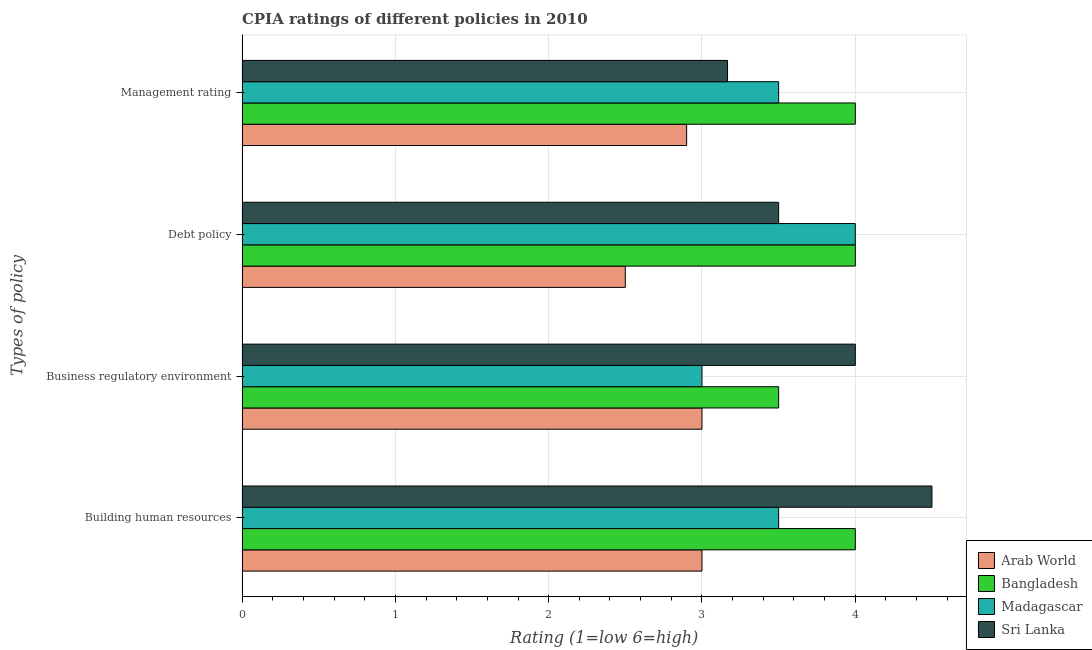How many groups of bars are there?
Provide a short and direct response. 4. How many bars are there on the 1st tick from the top?
Your answer should be very brief. 4. What is the label of the 2nd group of bars from the top?
Your answer should be compact. Debt policy. What is the cpia rating of debt policy in Arab World?
Provide a succinct answer. 2.5. Across all countries, what is the maximum cpia rating of building human resources?
Ensure brevity in your answer.  4.5. In which country was the cpia rating of building human resources maximum?
Offer a very short reply. Sri Lanka. In which country was the cpia rating of building human resources minimum?
Ensure brevity in your answer.  Arab World. What is the total cpia rating of business regulatory environment in the graph?
Make the answer very short. 13.5. What is the difference between the cpia rating of debt policy in Sri Lanka and the cpia rating of management in Arab World?
Make the answer very short. 0.6. What is the average cpia rating of management per country?
Give a very brief answer. 3.39. What is the difference between the cpia rating of management and cpia rating of debt policy in Arab World?
Your answer should be compact. 0.4. What is the ratio of the cpia rating of business regulatory environment in Sri Lanka to that in Bangladesh?
Your answer should be very brief. 1.14. Is the cpia rating of building human resources in Bangladesh less than that in Arab World?
Give a very brief answer. No. Is the difference between the cpia rating of debt policy in Bangladesh and Arab World greater than the difference between the cpia rating of building human resources in Bangladesh and Arab World?
Provide a short and direct response. Yes. What is the difference between the highest and the second highest cpia rating of debt policy?
Ensure brevity in your answer.  0. What is the difference between the highest and the lowest cpia rating of building human resources?
Your response must be concise. 1.5. Is the sum of the cpia rating of business regulatory environment in Madagascar and Sri Lanka greater than the maximum cpia rating of management across all countries?
Offer a very short reply. Yes. Is it the case that in every country, the sum of the cpia rating of building human resources and cpia rating of debt policy is greater than the sum of cpia rating of business regulatory environment and cpia rating of management?
Provide a short and direct response. No. What does the 1st bar from the top in Debt policy represents?
Your response must be concise. Sri Lanka. What does the 4th bar from the bottom in Debt policy represents?
Provide a succinct answer. Sri Lanka. How many bars are there?
Your answer should be compact. 16. Are all the bars in the graph horizontal?
Provide a short and direct response. Yes. What is the difference between two consecutive major ticks on the X-axis?
Provide a short and direct response. 1. Does the graph contain grids?
Your answer should be very brief. Yes. Where does the legend appear in the graph?
Your answer should be very brief. Bottom right. How many legend labels are there?
Your answer should be very brief. 4. How are the legend labels stacked?
Your response must be concise. Vertical. What is the title of the graph?
Provide a short and direct response. CPIA ratings of different policies in 2010. Does "Caribbean small states" appear as one of the legend labels in the graph?
Provide a succinct answer. No. What is the label or title of the X-axis?
Offer a terse response. Rating (1=low 6=high). What is the label or title of the Y-axis?
Your response must be concise. Types of policy. What is the Rating (1=low 6=high) of Arab World in Building human resources?
Your answer should be compact. 3. What is the Rating (1=low 6=high) in Bangladesh in Building human resources?
Provide a succinct answer. 4. What is the Rating (1=low 6=high) of Sri Lanka in Building human resources?
Ensure brevity in your answer.  4.5. What is the Rating (1=low 6=high) of Bangladesh in Business regulatory environment?
Provide a succinct answer. 3.5. What is the Rating (1=low 6=high) of Arab World in Debt policy?
Make the answer very short. 2.5. What is the Rating (1=low 6=high) of Madagascar in Debt policy?
Give a very brief answer. 4. What is the Rating (1=low 6=high) in Bangladesh in Management rating?
Provide a short and direct response. 4. What is the Rating (1=low 6=high) in Sri Lanka in Management rating?
Offer a terse response. 3.17. Across all Types of policy, what is the maximum Rating (1=low 6=high) in Bangladesh?
Your answer should be compact. 4. Across all Types of policy, what is the minimum Rating (1=low 6=high) of Bangladesh?
Give a very brief answer. 3.5. Across all Types of policy, what is the minimum Rating (1=low 6=high) in Sri Lanka?
Ensure brevity in your answer.  3.17. What is the total Rating (1=low 6=high) of Sri Lanka in the graph?
Provide a short and direct response. 15.17. What is the difference between the Rating (1=low 6=high) of Bangladesh in Building human resources and that in Business regulatory environment?
Your answer should be compact. 0.5. What is the difference between the Rating (1=low 6=high) of Sri Lanka in Building human resources and that in Business regulatory environment?
Offer a very short reply. 0.5. What is the difference between the Rating (1=low 6=high) of Arab World in Building human resources and that in Debt policy?
Offer a terse response. 0.5. What is the difference between the Rating (1=low 6=high) of Bangladesh in Building human resources and that in Debt policy?
Make the answer very short. 0. What is the difference between the Rating (1=low 6=high) in Bangladesh in Building human resources and that in Management rating?
Offer a very short reply. 0. What is the difference between the Rating (1=low 6=high) of Madagascar in Building human resources and that in Management rating?
Ensure brevity in your answer.  0. What is the difference between the Rating (1=low 6=high) of Sri Lanka in Building human resources and that in Management rating?
Make the answer very short. 1.33. What is the difference between the Rating (1=low 6=high) of Arab World in Building human resources and the Rating (1=low 6=high) of Bangladesh in Business regulatory environment?
Give a very brief answer. -0.5. What is the difference between the Rating (1=low 6=high) in Bangladesh in Building human resources and the Rating (1=low 6=high) in Madagascar in Business regulatory environment?
Make the answer very short. 1. What is the difference between the Rating (1=low 6=high) in Bangladesh in Building human resources and the Rating (1=low 6=high) in Sri Lanka in Business regulatory environment?
Make the answer very short. 0. What is the difference between the Rating (1=low 6=high) in Madagascar in Building human resources and the Rating (1=low 6=high) in Sri Lanka in Business regulatory environment?
Your response must be concise. -0.5. What is the difference between the Rating (1=low 6=high) of Arab World in Building human resources and the Rating (1=low 6=high) of Bangladesh in Debt policy?
Make the answer very short. -1. What is the difference between the Rating (1=low 6=high) of Arab World in Building human resources and the Rating (1=low 6=high) of Sri Lanka in Debt policy?
Ensure brevity in your answer.  -0.5. What is the difference between the Rating (1=low 6=high) of Arab World in Building human resources and the Rating (1=low 6=high) of Bangladesh in Management rating?
Your answer should be compact. -1. What is the difference between the Rating (1=low 6=high) of Arab World in Building human resources and the Rating (1=low 6=high) of Sri Lanka in Management rating?
Your answer should be very brief. -0.17. What is the difference between the Rating (1=low 6=high) of Bangladesh in Building human resources and the Rating (1=low 6=high) of Madagascar in Management rating?
Your response must be concise. 0.5. What is the difference between the Rating (1=low 6=high) in Arab World in Business regulatory environment and the Rating (1=low 6=high) in Bangladesh in Debt policy?
Offer a terse response. -1. What is the difference between the Rating (1=low 6=high) in Arab World in Business regulatory environment and the Rating (1=low 6=high) in Madagascar in Debt policy?
Keep it short and to the point. -1. What is the difference between the Rating (1=low 6=high) in Bangladesh in Business regulatory environment and the Rating (1=low 6=high) in Madagascar in Debt policy?
Make the answer very short. -0.5. What is the difference between the Rating (1=low 6=high) of Bangladesh in Business regulatory environment and the Rating (1=low 6=high) of Sri Lanka in Debt policy?
Make the answer very short. 0. What is the difference between the Rating (1=low 6=high) in Madagascar in Business regulatory environment and the Rating (1=low 6=high) in Sri Lanka in Debt policy?
Your response must be concise. -0.5. What is the difference between the Rating (1=low 6=high) of Arab World in Business regulatory environment and the Rating (1=low 6=high) of Bangladesh in Management rating?
Your answer should be very brief. -1. What is the difference between the Rating (1=low 6=high) in Arab World in Business regulatory environment and the Rating (1=low 6=high) in Sri Lanka in Management rating?
Offer a terse response. -0.17. What is the difference between the Rating (1=low 6=high) in Bangladesh in Business regulatory environment and the Rating (1=low 6=high) in Madagascar in Management rating?
Offer a terse response. 0. What is the difference between the Rating (1=low 6=high) of Bangladesh in Business regulatory environment and the Rating (1=low 6=high) of Sri Lanka in Management rating?
Provide a succinct answer. 0.33. What is the difference between the Rating (1=low 6=high) in Arab World in Debt policy and the Rating (1=low 6=high) in Madagascar in Management rating?
Make the answer very short. -1. What is the difference between the Rating (1=low 6=high) of Arab World in Debt policy and the Rating (1=low 6=high) of Sri Lanka in Management rating?
Keep it short and to the point. -0.67. What is the difference between the Rating (1=low 6=high) of Bangladesh in Debt policy and the Rating (1=low 6=high) of Sri Lanka in Management rating?
Provide a succinct answer. 0.83. What is the average Rating (1=low 6=high) of Arab World per Types of policy?
Keep it short and to the point. 2.85. What is the average Rating (1=low 6=high) of Bangladesh per Types of policy?
Your response must be concise. 3.88. What is the average Rating (1=low 6=high) of Madagascar per Types of policy?
Your answer should be compact. 3.5. What is the average Rating (1=low 6=high) in Sri Lanka per Types of policy?
Provide a succinct answer. 3.79. What is the difference between the Rating (1=low 6=high) of Arab World and Rating (1=low 6=high) of Bangladesh in Building human resources?
Make the answer very short. -1. What is the difference between the Rating (1=low 6=high) in Arab World and Rating (1=low 6=high) in Madagascar in Building human resources?
Your answer should be compact. -0.5. What is the difference between the Rating (1=low 6=high) of Arab World and Rating (1=low 6=high) of Sri Lanka in Building human resources?
Offer a very short reply. -1.5. What is the difference between the Rating (1=low 6=high) of Bangladesh and Rating (1=low 6=high) of Sri Lanka in Building human resources?
Give a very brief answer. -0.5. What is the difference between the Rating (1=low 6=high) in Madagascar and Rating (1=low 6=high) in Sri Lanka in Building human resources?
Make the answer very short. -1. What is the difference between the Rating (1=low 6=high) of Arab World and Rating (1=low 6=high) of Sri Lanka in Business regulatory environment?
Provide a succinct answer. -1. What is the difference between the Rating (1=low 6=high) in Bangladesh and Rating (1=low 6=high) in Sri Lanka in Business regulatory environment?
Offer a very short reply. -0.5. What is the difference between the Rating (1=low 6=high) of Madagascar and Rating (1=low 6=high) of Sri Lanka in Business regulatory environment?
Give a very brief answer. -1. What is the difference between the Rating (1=low 6=high) of Bangladesh and Rating (1=low 6=high) of Madagascar in Debt policy?
Make the answer very short. 0. What is the difference between the Rating (1=low 6=high) of Bangladesh and Rating (1=low 6=high) of Sri Lanka in Debt policy?
Your answer should be compact. 0.5. What is the difference between the Rating (1=low 6=high) in Arab World and Rating (1=low 6=high) in Bangladesh in Management rating?
Offer a very short reply. -1.1. What is the difference between the Rating (1=low 6=high) of Arab World and Rating (1=low 6=high) of Madagascar in Management rating?
Offer a terse response. -0.6. What is the difference between the Rating (1=low 6=high) in Arab World and Rating (1=low 6=high) in Sri Lanka in Management rating?
Give a very brief answer. -0.27. What is the difference between the Rating (1=low 6=high) of Bangladesh and Rating (1=low 6=high) of Madagascar in Management rating?
Keep it short and to the point. 0.5. What is the difference between the Rating (1=low 6=high) of Madagascar and Rating (1=low 6=high) of Sri Lanka in Management rating?
Your answer should be very brief. 0.33. What is the ratio of the Rating (1=low 6=high) of Arab World in Building human resources to that in Business regulatory environment?
Your answer should be very brief. 1. What is the ratio of the Rating (1=low 6=high) of Bangladesh in Building human resources to that in Business regulatory environment?
Keep it short and to the point. 1.14. What is the ratio of the Rating (1=low 6=high) of Bangladesh in Building human resources to that in Debt policy?
Your response must be concise. 1. What is the ratio of the Rating (1=low 6=high) of Sri Lanka in Building human resources to that in Debt policy?
Your answer should be very brief. 1.29. What is the ratio of the Rating (1=low 6=high) in Arab World in Building human resources to that in Management rating?
Your answer should be very brief. 1.03. What is the ratio of the Rating (1=low 6=high) in Madagascar in Building human resources to that in Management rating?
Your answer should be compact. 1. What is the ratio of the Rating (1=low 6=high) in Sri Lanka in Building human resources to that in Management rating?
Keep it short and to the point. 1.42. What is the ratio of the Rating (1=low 6=high) of Arab World in Business regulatory environment to that in Debt policy?
Your answer should be very brief. 1.2. What is the ratio of the Rating (1=low 6=high) in Bangladesh in Business regulatory environment to that in Debt policy?
Ensure brevity in your answer.  0.88. What is the ratio of the Rating (1=low 6=high) in Sri Lanka in Business regulatory environment to that in Debt policy?
Your answer should be compact. 1.14. What is the ratio of the Rating (1=low 6=high) in Arab World in Business regulatory environment to that in Management rating?
Provide a succinct answer. 1.03. What is the ratio of the Rating (1=low 6=high) of Bangladesh in Business regulatory environment to that in Management rating?
Offer a very short reply. 0.88. What is the ratio of the Rating (1=low 6=high) in Sri Lanka in Business regulatory environment to that in Management rating?
Give a very brief answer. 1.26. What is the ratio of the Rating (1=low 6=high) in Arab World in Debt policy to that in Management rating?
Make the answer very short. 0.86. What is the ratio of the Rating (1=low 6=high) of Madagascar in Debt policy to that in Management rating?
Keep it short and to the point. 1.14. What is the ratio of the Rating (1=low 6=high) in Sri Lanka in Debt policy to that in Management rating?
Provide a short and direct response. 1.11. What is the difference between the highest and the second highest Rating (1=low 6=high) in Arab World?
Make the answer very short. 0. What is the difference between the highest and the second highest Rating (1=low 6=high) in Bangladesh?
Keep it short and to the point. 0. What is the difference between the highest and the second highest Rating (1=low 6=high) of Madagascar?
Your answer should be compact. 0.5. What is the difference between the highest and the second highest Rating (1=low 6=high) of Sri Lanka?
Your answer should be very brief. 0.5. What is the difference between the highest and the lowest Rating (1=low 6=high) of Arab World?
Offer a terse response. 0.5. What is the difference between the highest and the lowest Rating (1=low 6=high) of Bangladesh?
Offer a very short reply. 0.5. What is the difference between the highest and the lowest Rating (1=low 6=high) of Sri Lanka?
Your response must be concise. 1.33. 